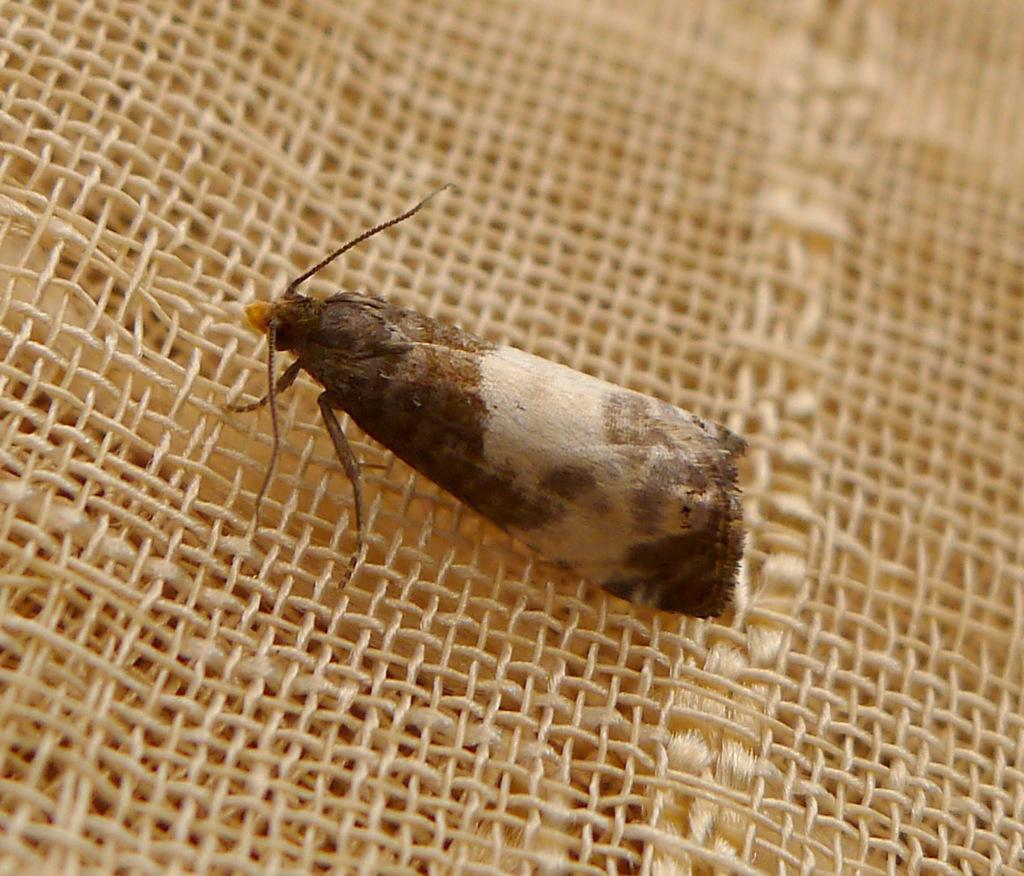What type of insect is in the image? There is a moth in the image. What is the moth resting on in the image? The moth is on a cream surface. How many babies are present in the image? There are no babies present in the image; it features a moth on a cream surface. What shape is the moth in the image? The moth is not a shape; it is a living organism. The question is based on the absurd topic "circle" and cannot be answered definitively from the given facts. 